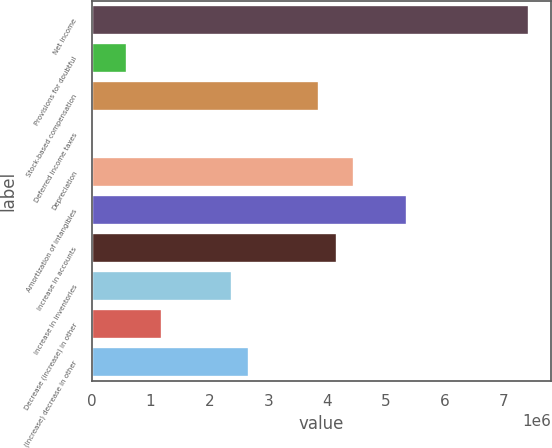Convert chart. <chart><loc_0><loc_0><loc_500><loc_500><bar_chart><fcel>Net income<fcel>Provisions for doubtful<fcel>Stock-based compensation<fcel>Deferred income taxes<fcel>Depreciation<fcel>Amortization of intangibles<fcel>Increase in accounts<fcel>Increase in inventories<fcel>Decrease (increase) in other<fcel>(Increase) decrease in other<nl><fcel>7.43004e+06<fcel>594558<fcel>3.8637e+06<fcel>169<fcel>4.45809e+06<fcel>5.34967e+06<fcel>4.16089e+06<fcel>2.37773e+06<fcel>1.18895e+06<fcel>2.67492e+06<nl></chart> 